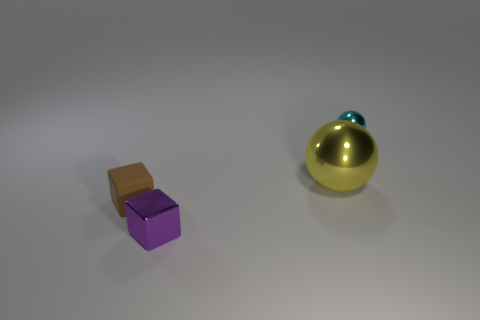Add 1 metal blocks. How many objects exist? 5 Subtract all large brown matte cubes. Subtract all big yellow spheres. How many objects are left? 3 Add 4 small purple metallic things. How many small purple metallic things are left? 5 Add 3 large purple rubber cylinders. How many large purple rubber cylinders exist? 3 Subtract 1 brown blocks. How many objects are left? 3 